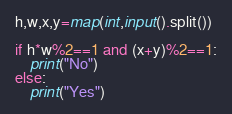<code> <loc_0><loc_0><loc_500><loc_500><_Python_>h,w,x,y=map(int,input().split())

if h*w%2==1 and (x+y)%2==1:
    print("No")
else:
    print("Yes")

</code> 